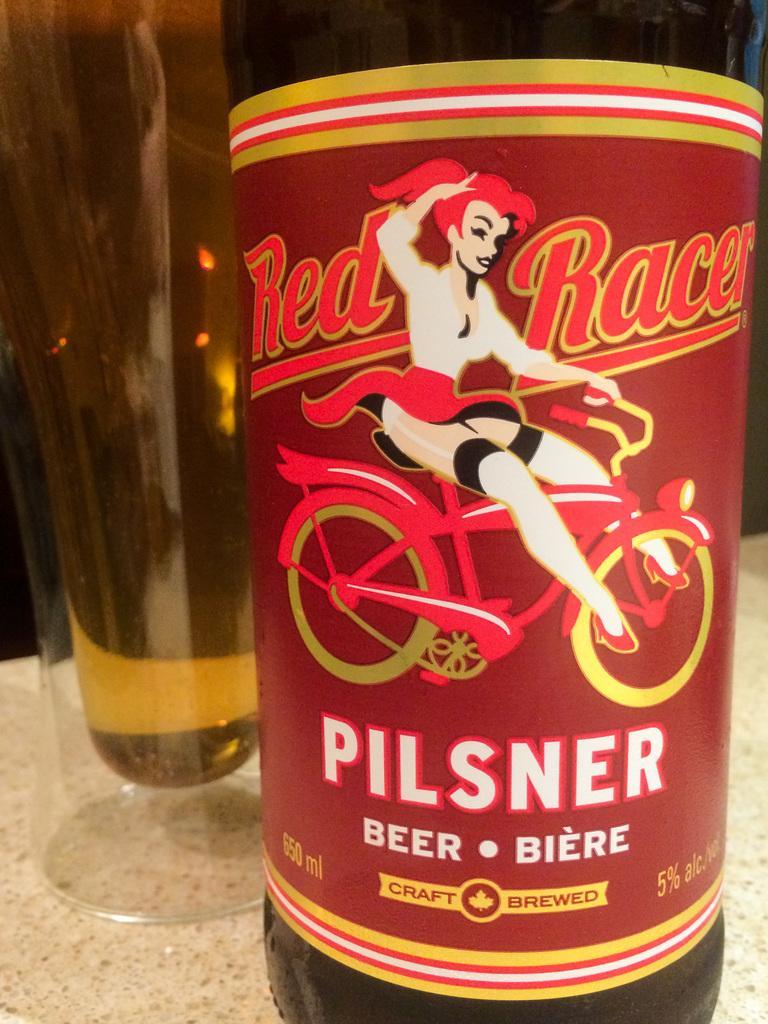Describe this image in one or two sentences. The photo of this picture we can see a bottle of drink and some class object and we can see the text and a picture of a person riding bicycle on the paper attached to the water and background can see some other objects 